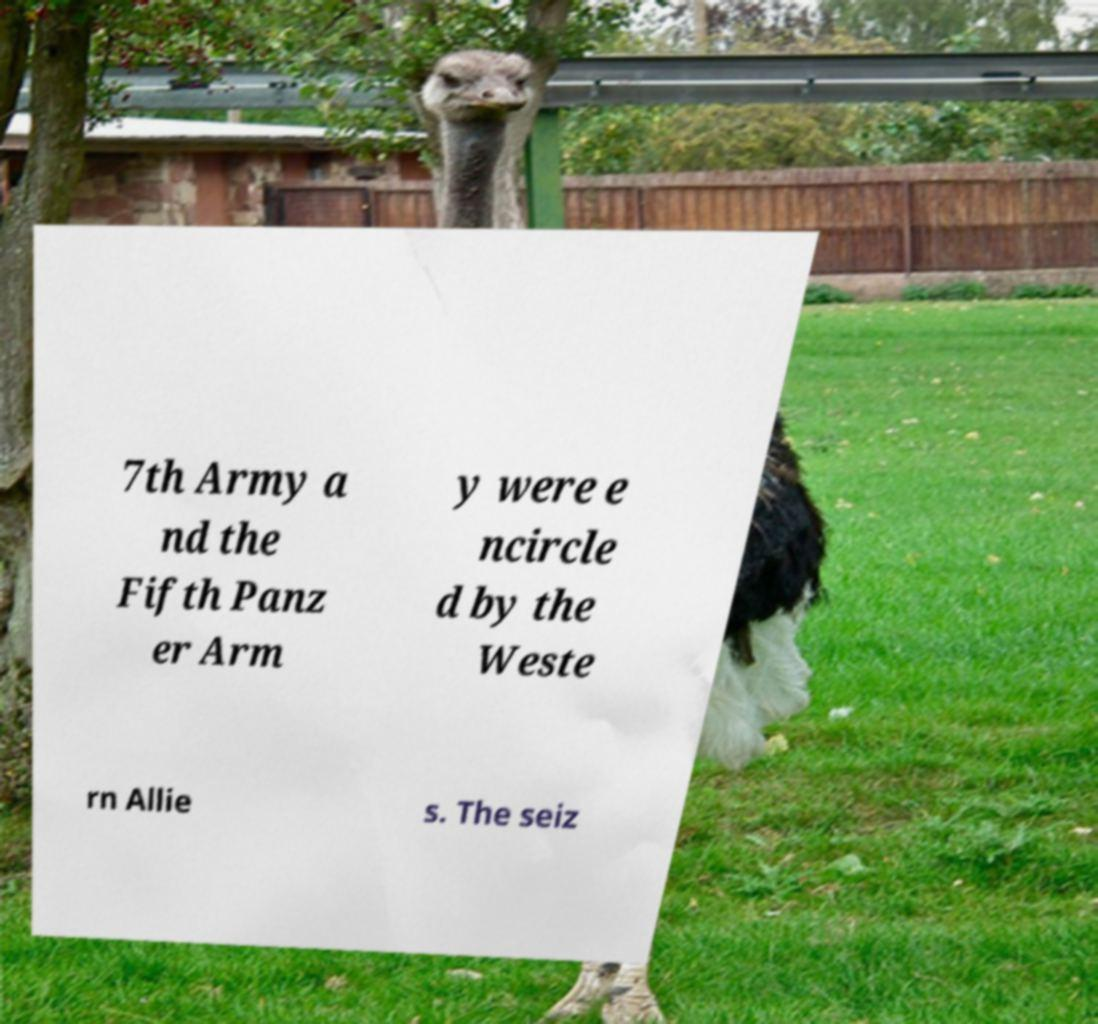Could you extract and type out the text from this image? 7th Army a nd the Fifth Panz er Arm y were e ncircle d by the Weste rn Allie s. The seiz 